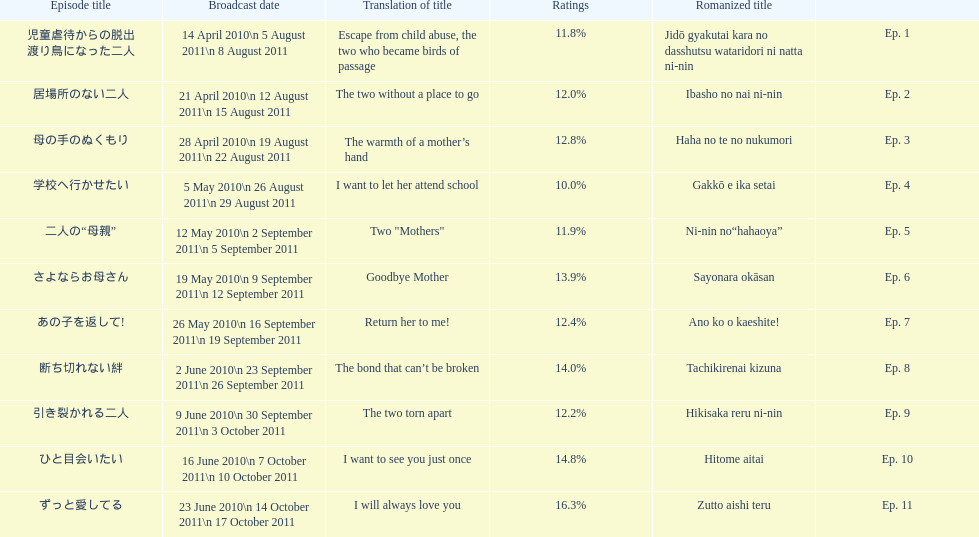How many episode total are there? 11. 